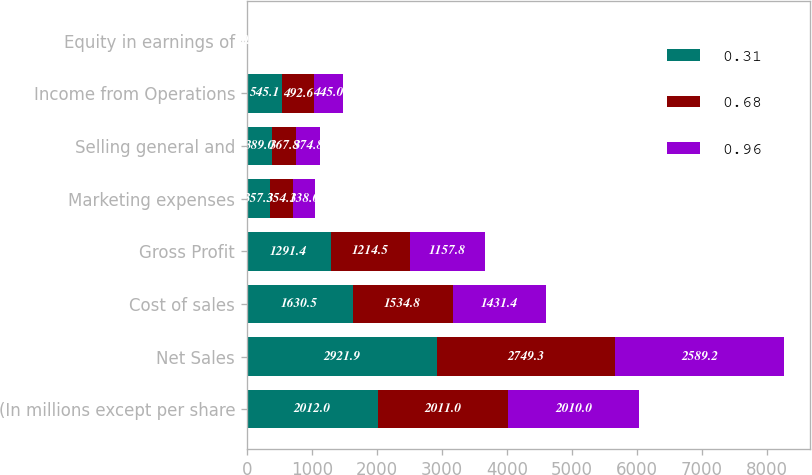Convert chart. <chart><loc_0><loc_0><loc_500><loc_500><stacked_bar_chart><ecel><fcel>(In millions except per share<fcel>Net Sales<fcel>Cost of sales<fcel>Gross Profit<fcel>Marketing expenses<fcel>Selling general and<fcel>Income from Operations<fcel>Equity in earnings of<nl><fcel>0.31<fcel>2012<fcel>2921.9<fcel>1630.5<fcel>1291.4<fcel>357.3<fcel>389<fcel>545.1<fcel>8.9<nl><fcel>0.68<fcel>2011<fcel>2749.3<fcel>1534.8<fcel>1214.5<fcel>354.1<fcel>367.8<fcel>492.6<fcel>10<nl><fcel>0.96<fcel>2010<fcel>2589.2<fcel>1431.4<fcel>1157.8<fcel>338<fcel>374.8<fcel>445<fcel>5<nl></chart> 